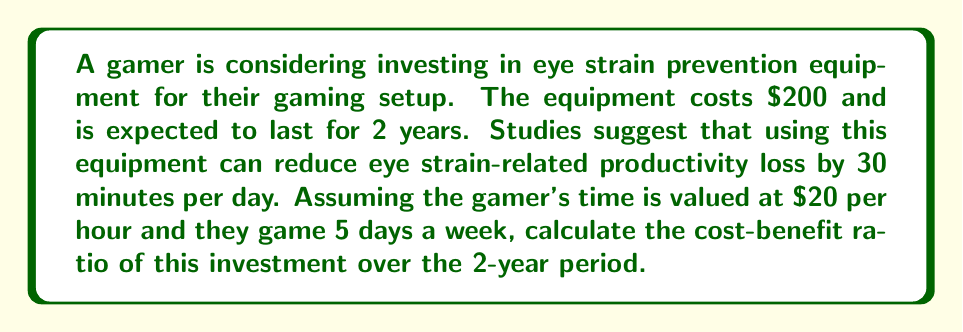Solve this math problem. To solve this problem, we need to:
1. Calculate the total cost of the investment
2. Calculate the total benefit over 2 years
3. Compute the cost-benefit ratio

Step 1: Total cost
The total cost is simply the price of the equipment: $200

Step 2: Total benefit
First, let's calculate the daily benefit:
$$ \text{Daily Benefit} = 0.5 \text{ hours} \times \$20/\text{hour} = \$10/\text{day} $$

Now, let's calculate the weekly benefit:
$$ \text{Weekly Benefit} = \$10/\text{day} \times 5 \text{ days} = \$50/\text{week} $$

The total benefit over 2 years (104 weeks):
$$ \text{Total Benefit} = \$50/\text{week} \times 104 \text{ weeks} = \$5,200 $$

Step 3: Cost-benefit ratio
The cost-benefit ratio is calculated as:
$$ \text{Cost-Benefit Ratio} = \frac{\text{Total Cost}}{\text{Total Benefit}} $$

Substituting our values:
$$ \text{Cost-Benefit Ratio} = \frac{\$200}{\$5,200} = \frac{1}{26} \approx 0.0385 $$
Answer: The cost-benefit ratio is $\frac{1}{26}$ or approximately 0.0385. 